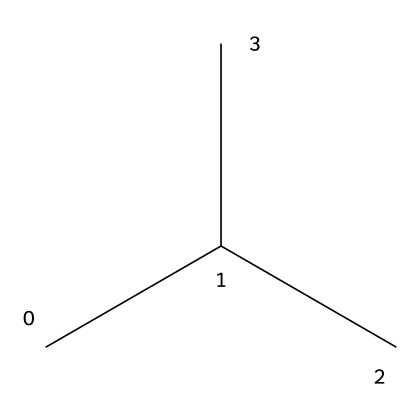What is the name of the compound represented by this structure? The SMILES representation CC(C)C corresponds to isobutane, which has four carbon atoms in total. The name can be deduced from the arrangement and the fact that it is an isomer of butane with a branched structure.
Answer: isobutane How many carbon atoms are in isobutane? From the SMILES structure CC(C)C, we can count the carbon symbols (C). There are four carbon atoms in total.
Answer: four What type of chemical structure does isobutane have? The structure depicted by the SMILES is branched since it shows a central carbon with additional carbon atoms branching off. This characteristic distinguishes isobutane from normal butane, which is linear.
Answer: branched What is the molecular formula of isobutane? By analyzing the number of carbons and hydrogens in the structure, we find that isobutane has four carbons and ten hydrogens. The molecular formula can thus be constructed as C4H10.
Answer: C4H10 What type of bonding is primarily present in isobutane? The structural formula indicates single bonds between carbon atoms and carbon-hydrogen bonds, characteristic of aliphatic compounds. Aliphatic compounds typically contain only single bonds unless otherwise specified.
Answer: single bonds Considering isobutane is a gas at room temperature, what is its phase? Given that isobutane is commonly stored as a gas and is known for its use in compressed air dusters, it would be in the gaseous phase at room temperature.
Answer: gas Is isobutane a saturated or unsaturated compound? Looking at the structure, which consists entirely of single bonds without any double or triple bonds, we can identify isobutane as a saturated compound. Saturated compounds have the maximum number of hydrogen atoms attached to carbons.
Answer: saturated 